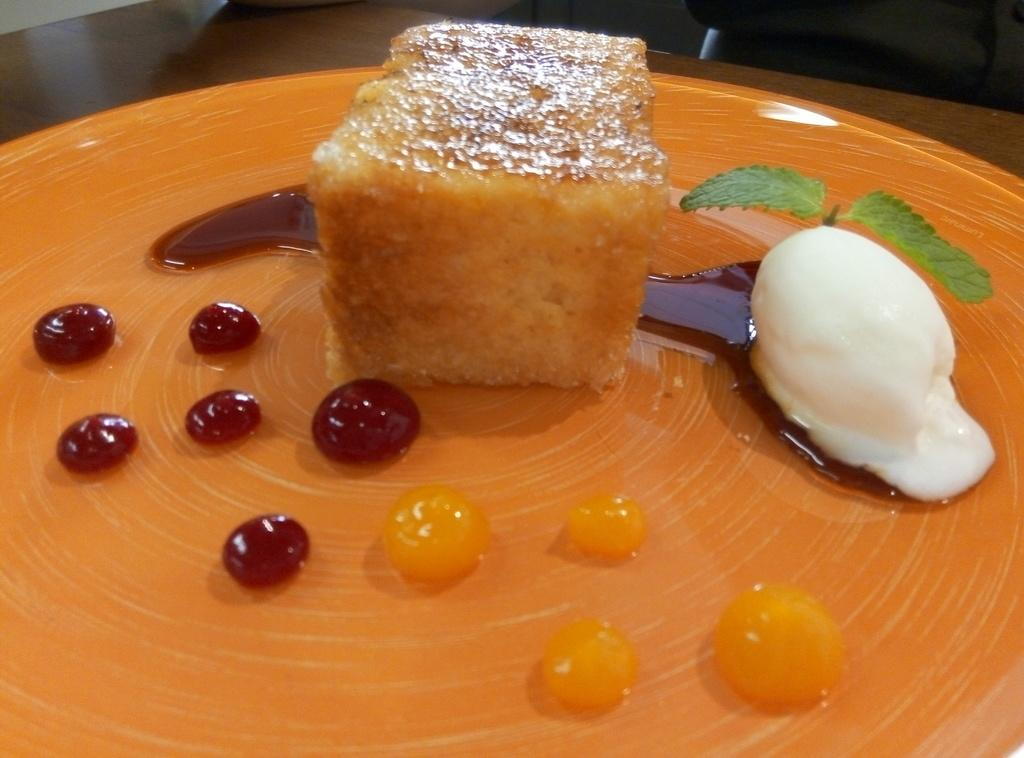What is on the plate that is visible in the image? There is food on a plate in the image. What color is the plate? The plate is orange in color. Where is the plate located in the image? The plate is placed on a table. What additional items can be seen in the image? There are two mint leaves in the image. Can you hear the agreement between the food and the mint leaves in the image? There is no audible agreement between the food and the mint leaves in the image, as it is a still image and not a recording of sound. 